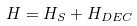<formula> <loc_0><loc_0><loc_500><loc_500>H = H _ { S } + H _ { D E C }</formula> 